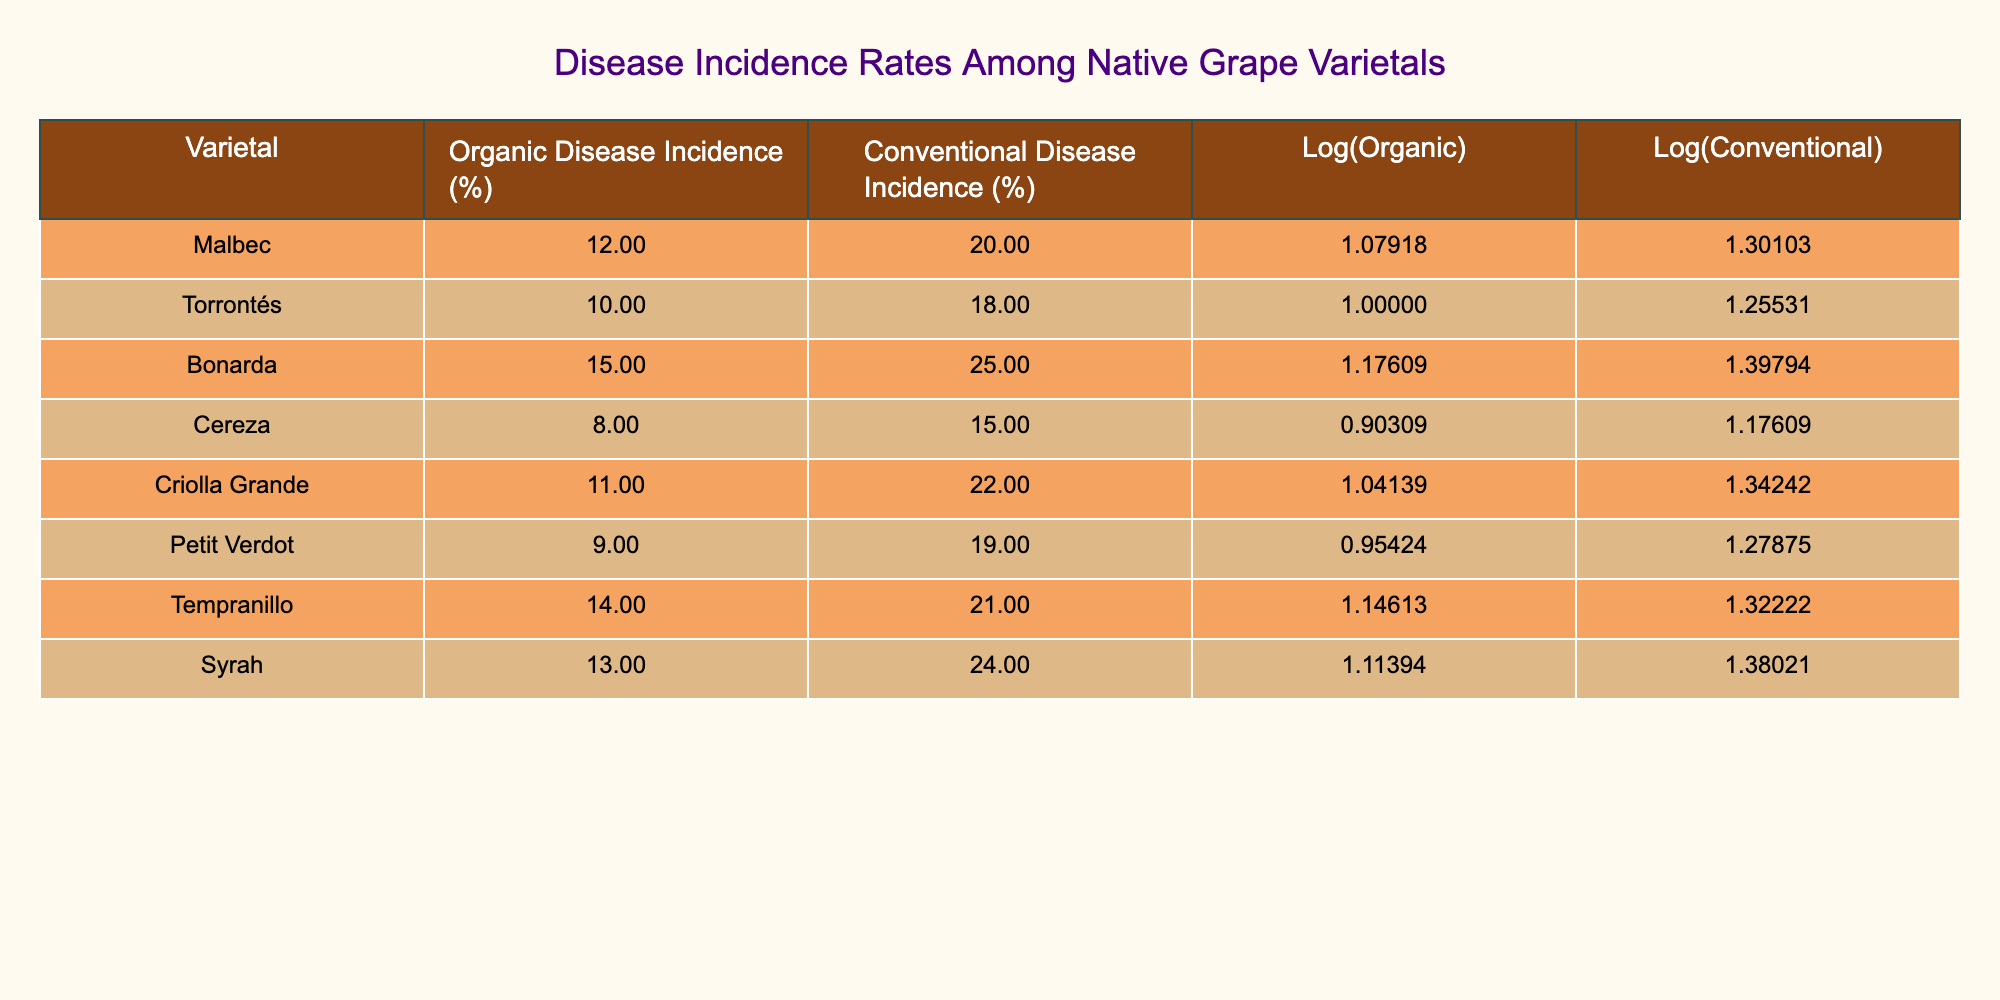What is the disease incidence rate for Malbec in organic farming? The table directly shows the disease incidence rate for Malbec under organic farming in the second column, which is 12%.
Answer: 12% Which varietal has the highest disease incidence in conventional farming? By comparing the values in the conventional disease incidence percentage column, Bonarda has the highest rate with 25%.
Answer: 25% What is the difference in disease incidence rates between organic and conventional farming for Torrontés? For Torrontés, the organic rate is 10% and the conventional rate is 18%. The difference is calculated as 18% - 10% = 8%.
Answer: 8% Is the disease incidence rate for Criolla Grande in organic farming greater than 10%? The table indicates that the disease incidence rate for Criolla Grande in organic farming is 11%, which is indeed greater than 10%.
Answer: Yes What is the average disease incidence rate for all varietals in organic farming? To find the average, sum all organic disease incidence rates: 12 + 10 + 15 + 8 + 11 + 9 + 14 + 13 = 92. There are 8 varietals, so the average is 92 / 8 = 11.5%.
Answer: 11.5% What is the ratio of the disease incidence rate between organic and conventional farming for Syrah? The organic incidence for Syrah is 13% and conventional is 24%. The ratio is therefore 13% : 24%. This can be simplified to approximately 0.54 when calculated as a decimal.
Answer: 0.54 Are the disease incidence rates for all varietals lower in organic farming compared to conventional farming? By reviewing the table, Criolla Grande, Petit Verdot, and Cereza have rates (11%, 9%, 8%) that are lower than their conventional counterparts (22%, 19%, 15%). Thus, it is not true that all are lower.
Answer: No What is the logarithmic difference in disease incidence rates for Bonarda? For Bonarda, the logarithmic values are Log(Organic) = 1.17609 and Log(Conventional) = 1.39794. The difference is calculated as 1.39794 - 1.17609 = 0.22185.
Answer: 0.22185 